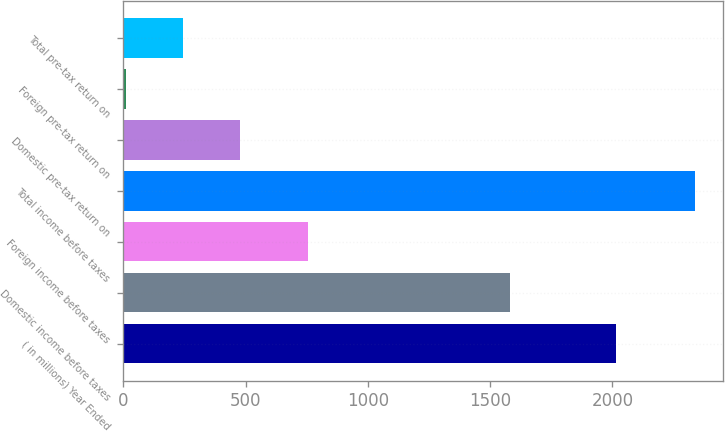Convert chart. <chart><loc_0><loc_0><loc_500><loc_500><bar_chart><fcel>( in millions) Year Ended<fcel>Domestic income before taxes<fcel>Foreign income before taxes<fcel>Total income before taxes<fcel>Domestic pre-tax return on<fcel>Foreign pre-tax return on<fcel>Total pre-tax return on<nl><fcel>2015<fcel>1581.6<fcel>755.5<fcel>2337.1<fcel>475.34<fcel>9.9<fcel>242.62<nl></chart> 